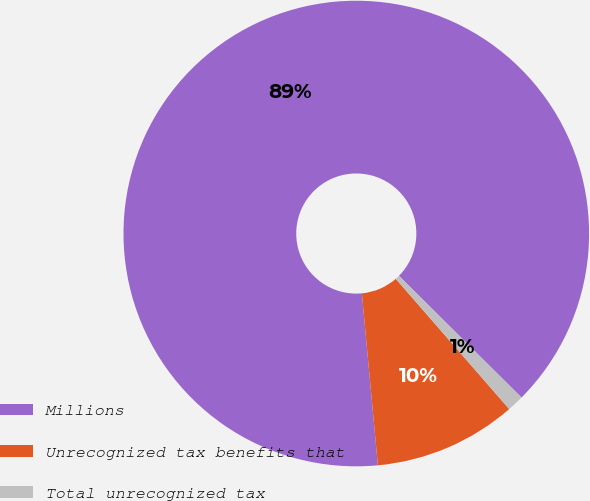<chart> <loc_0><loc_0><loc_500><loc_500><pie_chart><fcel>Millions<fcel>Unrecognized tax benefits that<fcel>Total unrecognized tax<nl><fcel>88.92%<fcel>9.93%<fcel>1.15%<nl></chart> 